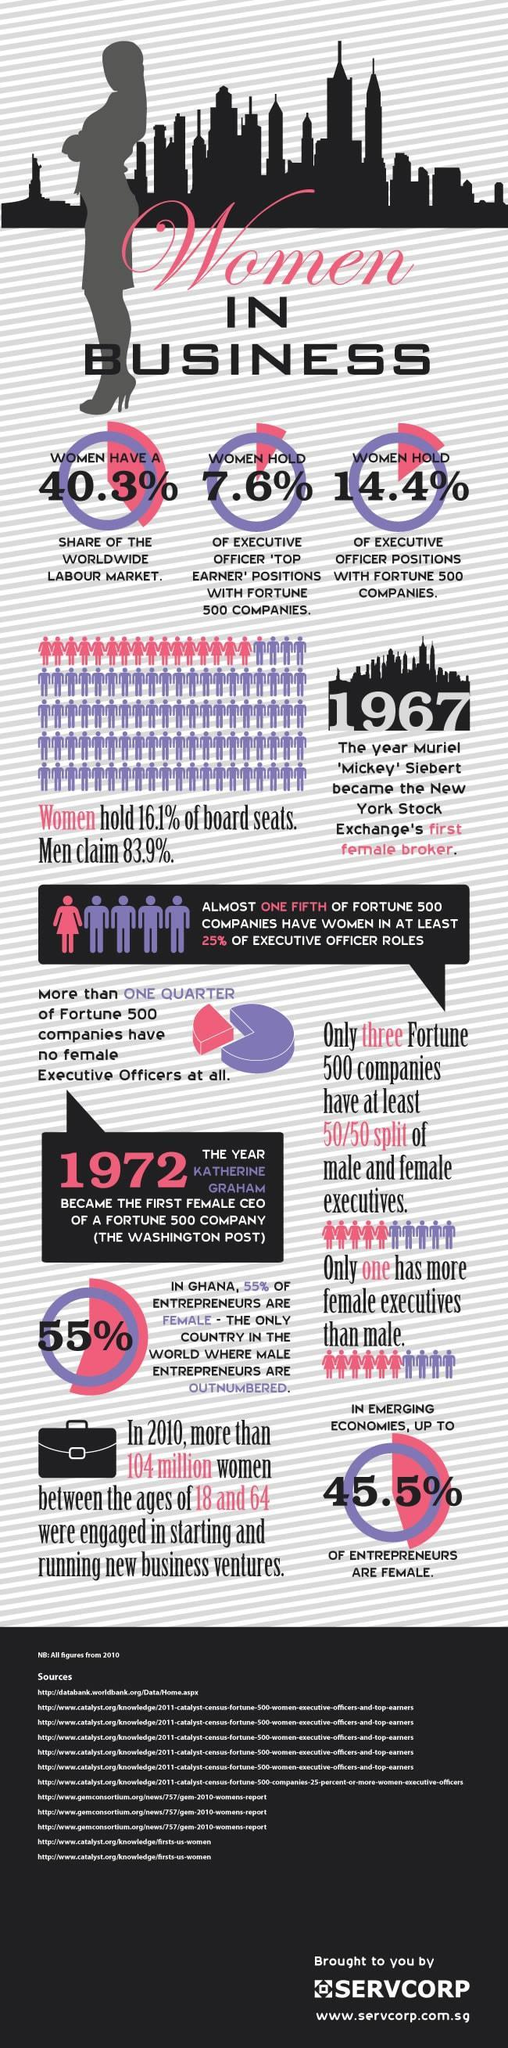What is the share of women in the worldwide labour market
Answer the question with a short phrase. 40.3% How many years after the first female broker, did a fortune 500 company gets its first female CEO 5 When did New York Stock Exchange have its first female broker 1967 In emerging economies, what % of entrepreneurs are not females 54.5 More than what % of Fortune 500 companies have no female executive officers at all 25 What % of women hold executive officer positions with fortune 500 companies 14.4% What % of women hold executive officer top earner positions with fortune 500 companies 7.6% 